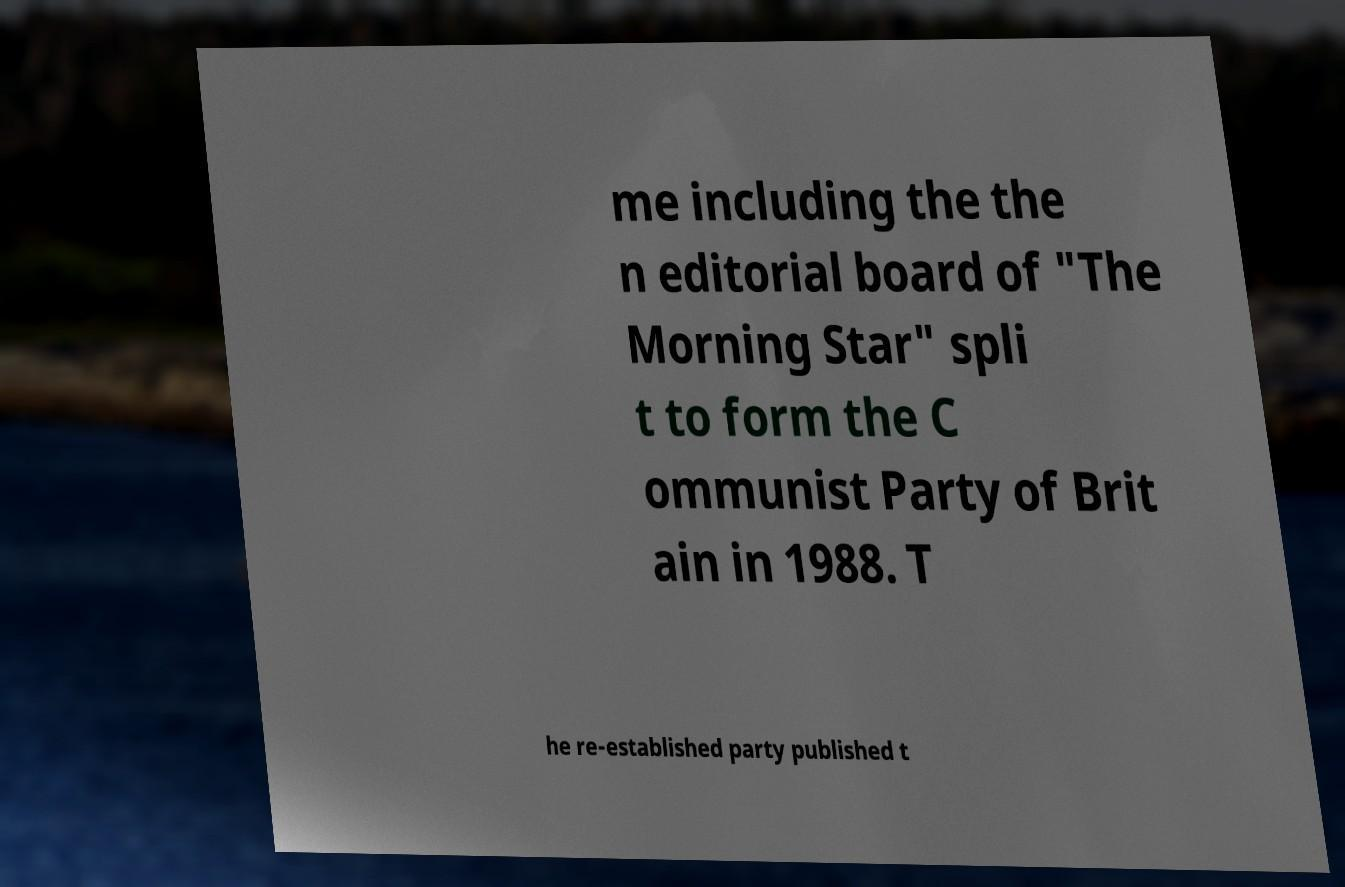There's text embedded in this image that I need extracted. Can you transcribe it verbatim? me including the the n editorial board of "The Morning Star" spli t to form the C ommunist Party of Brit ain in 1988. T he re-established party published t 